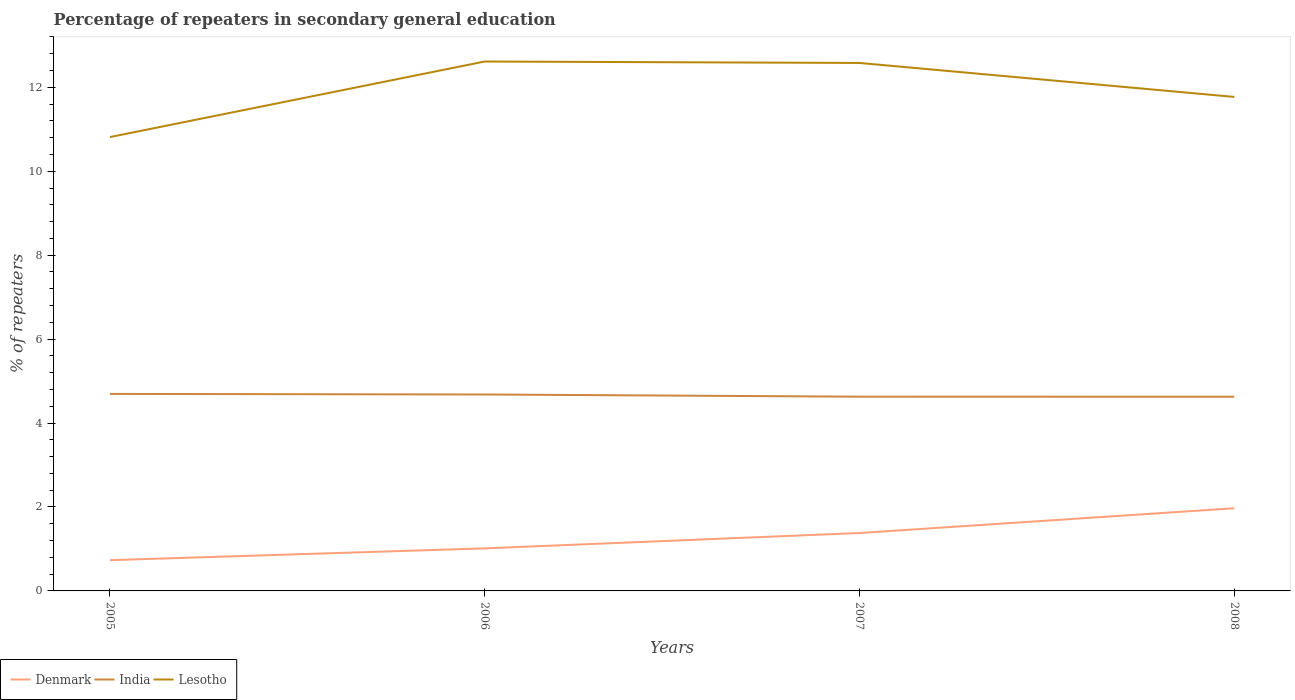How many different coloured lines are there?
Keep it short and to the point. 3. Does the line corresponding to Lesotho intersect with the line corresponding to India?
Your answer should be very brief. No. Across all years, what is the maximum percentage of repeaters in secondary general education in India?
Give a very brief answer. 4.63. In which year was the percentage of repeaters in secondary general education in India maximum?
Ensure brevity in your answer.  2008. What is the total percentage of repeaters in secondary general education in Denmark in the graph?
Provide a succinct answer. -0.65. What is the difference between the highest and the second highest percentage of repeaters in secondary general education in Lesotho?
Keep it short and to the point. 1.8. What is the difference between the highest and the lowest percentage of repeaters in secondary general education in India?
Provide a succinct answer. 2. How many lines are there?
Provide a succinct answer. 3. How many years are there in the graph?
Give a very brief answer. 4. Does the graph contain grids?
Give a very brief answer. No. Where does the legend appear in the graph?
Your answer should be very brief. Bottom left. How many legend labels are there?
Give a very brief answer. 3. How are the legend labels stacked?
Provide a short and direct response. Horizontal. What is the title of the graph?
Keep it short and to the point. Percentage of repeaters in secondary general education. Does "Iceland" appear as one of the legend labels in the graph?
Your answer should be compact. No. What is the label or title of the X-axis?
Ensure brevity in your answer.  Years. What is the label or title of the Y-axis?
Give a very brief answer. % of repeaters. What is the % of repeaters in Denmark in 2005?
Your answer should be very brief. 0.73. What is the % of repeaters in India in 2005?
Offer a terse response. 4.69. What is the % of repeaters of Lesotho in 2005?
Keep it short and to the point. 10.81. What is the % of repeaters in Denmark in 2006?
Give a very brief answer. 1.01. What is the % of repeaters in India in 2006?
Provide a succinct answer. 4.68. What is the % of repeaters of Lesotho in 2006?
Your answer should be compact. 12.62. What is the % of repeaters in Denmark in 2007?
Make the answer very short. 1.38. What is the % of repeaters of India in 2007?
Keep it short and to the point. 4.63. What is the % of repeaters of Lesotho in 2007?
Provide a succinct answer. 12.58. What is the % of repeaters in Denmark in 2008?
Ensure brevity in your answer.  1.97. What is the % of repeaters in India in 2008?
Your answer should be compact. 4.63. What is the % of repeaters in Lesotho in 2008?
Your answer should be compact. 11.77. Across all years, what is the maximum % of repeaters of Denmark?
Keep it short and to the point. 1.97. Across all years, what is the maximum % of repeaters in India?
Offer a terse response. 4.69. Across all years, what is the maximum % of repeaters in Lesotho?
Keep it short and to the point. 12.62. Across all years, what is the minimum % of repeaters in Denmark?
Your answer should be very brief. 0.73. Across all years, what is the minimum % of repeaters in India?
Your answer should be compact. 4.63. Across all years, what is the minimum % of repeaters of Lesotho?
Your answer should be compact. 10.81. What is the total % of repeaters in Denmark in the graph?
Give a very brief answer. 5.1. What is the total % of repeaters in India in the graph?
Your response must be concise. 18.63. What is the total % of repeaters of Lesotho in the graph?
Ensure brevity in your answer.  47.78. What is the difference between the % of repeaters in Denmark in 2005 and that in 2006?
Your response must be concise. -0.28. What is the difference between the % of repeaters of India in 2005 and that in 2006?
Provide a succinct answer. 0.01. What is the difference between the % of repeaters of Lesotho in 2005 and that in 2006?
Make the answer very short. -1.8. What is the difference between the % of repeaters of Denmark in 2005 and that in 2007?
Give a very brief answer. -0.65. What is the difference between the % of repeaters in India in 2005 and that in 2007?
Ensure brevity in your answer.  0.07. What is the difference between the % of repeaters in Lesotho in 2005 and that in 2007?
Offer a terse response. -1.77. What is the difference between the % of repeaters in Denmark in 2005 and that in 2008?
Your response must be concise. -1.24. What is the difference between the % of repeaters in India in 2005 and that in 2008?
Your answer should be very brief. 0.07. What is the difference between the % of repeaters in Lesotho in 2005 and that in 2008?
Keep it short and to the point. -0.96. What is the difference between the % of repeaters of Denmark in 2006 and that in 2007?
Provide a succinct answer. -0.37. What is the difference between the % of repeaters in India in 2006 and that in 2007?
Keep it short and to the point. 0.05. What is the difference between the % of repeaters of Lesotho in 2006 and that in 2007?
Provide a succinct answer. 0.03. What is the difference between the % of repeaters of Denmark in 2006 and that in 2008?
Your answer should be very brief. -0.96. What is the difference between the % of repeaters of India in 2006 and that in 2008?
Offer a very short reply. 0.05. What is the difference between the % of repeaters of Lesotho in 2006 and that in 2008?
Keep it short and to the point. 0.84. What is the difference between the % of repeaters in Denmark in 2007 and that in 2008?
Make the answer very short. -0.59. What is the difference between the % of repeaters in India in 2007 and that in 2008?
Provide a short and direct response. 0. What is the difference between the % of repeaters in Lesotho in 2007 and that in 2008?
Provide a short and direct response. 0.81. What is the difference between the % of repeaters of Denmark in 2005 and the % of repeaters of India in 2006?
Offer a terse response. -3.95. What is the difference between the % of repeaters of Denmark in 2005 and the % of repeaters of Lesotho in 2006?
Provide a succinct answer. -11.88. What is the difference between the % of repeaters of India in 2005 and the % of repeaters of Lesotho in 2006?
Provide a short and direct response. -7.92. What is the difference between the % of repeaters of Denmark in 2005 and the % of repeaters of India in 2007?
Provide a short and direct response. -3.9. What is the difference between the % of repeaters of Denmark in 2005 and the % of repeaters of Lesotho in 2007?
Make the answer very short. -11.85. What is the difference between the % of repeaters in India in 2005 and the % of repeaters in Lesotho in 2007?
Keep it short and to the point. -7.89. What is the difference between the % of repeaters of Denmark in 2005 and the % of repeaters of India in 2008?
Your answer should be compact. -3.89. What is the difference between the % of repeaters of Denmark in 2005 and the % of repeaters of Lesotho in 2008?
Your answer should be compact. -11.04. What is the difference between the % of repeaters in India in 2005 and the % of repeaters in Lesotho in 2008?
Keep it short and to the point. -7.08. What is the difference between the % of repeaters in Denmark in 2006 and the % of repeaters in India in 2007?
Your answer should be compact. -3.61. What is the difference between the % of repeaters of Denmark in 2006 and the % of repeaters of Lesotho in 2007?
Offer a terse response. -11.57. What is the difference between the % of repeaters of India in 2006 and the % of repeaters of Lesotho in 2007?
Offer a very short reply. -7.9. What is the difference between the % of repeaters in Denmark in 2006 and the % of repeaters in India in 2008?
Make the answer very short. -3.61. What is the difference between the % of repeaters of Denmark in 2006 and the % of repeaters of Lesotho in 2008?
Provide a short and direct response. -10.76. What is the difference between the % of repeaters of India in 2006 and the % of repeaters of Lesotho in 2008?
Ensure brevity in your answer.  -7.09. What is the difference between the % of repeaters in Denmark in 2007 and the % of repeaters in India in 2008?
Provide a short and direct response. -3.25. What is the difference between the % of repeaters in Denmark in 2007 and the % of repeaters in Lesotho in 2008?
Your answer should be compact. -10.39. What is the difference between the % of repeaters in India in 2007 and the % of repeaters in Lesotho in 2008?
Offer a very short reply. -7.14. What is the average % of repeaters of Denmark per year?
Provide a succinct answer. 1.27. What is the average % of repeaters of India per year?
Give a very brief answer. 4.66. What is the average % of repeaters in Lesotho per year?
Offer a terse response. 11.95. In the year 2005, what is the difference between the % of repeaters of Denmark and % of repeaters of India?
Your answer should be very brief. -3.96. In the year 2005, what is the difference between the % of repeaters of Denmark and % of repeaters of Lesotho?
Your answer should be very brief. -10.08. In the year 2005, what is the difference between the % of repeaters in India and % of repeaters in Lesotho?
Provide a succinct answer. -6.12. In the year 2006, what is the difference between the % of repeaters of Denmark and % of repeaters of India?
Provide a short and direct response. -3.67. In the year 2006, what is the difference between the % of repeaters in Denmark and % of repeaters in Lesotho?
Give a very brief answer. -11.6. In the year 2006, what is the difference between the % of repeaters in India and % of repeaters in Lesotho?
Keep it short and to the point. -7.93. In the year 2007, what is the difference between the % of repeaters of Denmark and % of repeaters of India?
Provide a short and direct response. -3.25. In the year 2007, what is the difference between the % of repeaters of Denmark and % of repeaters of Lesotho?
Provide a succinct answer. -11.2. In the year 2007, what is the difference between the % of repeaters in India and % of repeaters in Lesotho?
Your response must be concise. -7.95. In the year 2008, what is the difference between the % of repeaters of Denmark and % of repeaters of India?
Your answer should be very brief. -2.66. In the year 2008, what is the difference between the % of repeaters of Denmark and % of repeaters of Lesotho?
Your response must be concise. -9.8. In the year 2008, what is the difference between the % of repeaters of India and % of repeaters of Lesotho?
Your answer should be very brief. -7.14. What is the ratio of the % of repeaters in Denmark in 2005 to that in 2006?
Your response must be concise. 0.72. What is the ratio of the % of repeaters in India in 2005 to that in 2006?
Your answer should be compact. 1. What is the ratio of the % of repeaters in Lesotho in 2005 to that in 2006?
Make the answer very short. 0.86. What is the ratio of the % of repeaters of Denmark in 2005 to that in 2007?
Make the answer very short. 0.53. What is the ratio of the % of repeaters in India in 2005 to that in 2007?
Your response must be concise. 1.01. What is the ratio of the % of repeaters in Lesotho in 2005 to that in 2007?
Your answer should be compact. 0.86. What is the ratio of the % of repeaters in Denmark in 2005 to that in 2008?
Provide a succinct answer. 0.37. What is the ratio of the % of repeaters of India in 2005 to that in 2008?
Ensure brevity in your answer.  1.01. What is the ratio of the % of repeaters in Lesotho in 2005 to that in 2008?
Make the answer very short. 0.92. What is the ratio of the % of repeaters in Denmark in 2006 to that in 2007?
Your answer should be very brief. 0.73. What is the ratio of the % of repeaters of India in 2006 to that in 2007?
Provide a short and direct response. 1.01. What is the ratio of the % of repeaters in Denmark in 2006 to that in 2008?
Your answer should be very brief. 0.51. What is the ratio of the % of repeaters in India in 2006 to that in 2008?
Keep it short and to the point. 1.01. What is the ratio of the % of repeaters in Lesotho in 2006 to that in 2008?
Keep it short and to the point. 1.07. What is the ratio of the % of repeaters of Denmark in 2007 to that in 2008?
Keep it short and to the point. 0.7. What is the ratio of the % of repeaters in Lesotho in 2007 to that in 2008?
Make the answer very short. 1.07. What is the difference between the highest and the second highest % of repeaters of Denmark?
Your answer should be very brief. 0.59. What is the difference between the highest and the second highest % of repeaters in India?
Your answer should be compact. 0.01. What is the difference between the highest and the second highest % of repeaters of Lesotho?
Make the answer very short. 0.03. What is the difference between the highest and the lowest % of repeaters of Denmark?
Keep it short and to the point. 1.24. What is the difference between the highest and the lowest % of repeaters of India?
Offer a terse response. 0.07. What is the difference between the highest and the lowest % of repeaters of Lesotho?
Your answer should be compact. 1.8. 